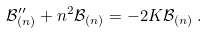<formula> <loc_0><loc_0><loc_500><loc_500>\mathcal { B } _ { ( n ) } ^ { \prime \prime } + n ^ { 2 } \mathcal { B } _ { ( n ) } = - 2 K \mathcal { B } _ { ( n ) } \, .</formula> 